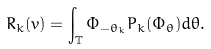Convert formula to latex. <formula><loc_0><loc_0><loc_500><loc_500>R _ { k } ( v ) = \int _ { \mathbb { T } } \Phi _ { - \theta _ { k } } P _ { k } ( \Phi _ { \theta } ) d \theta .</formula> 